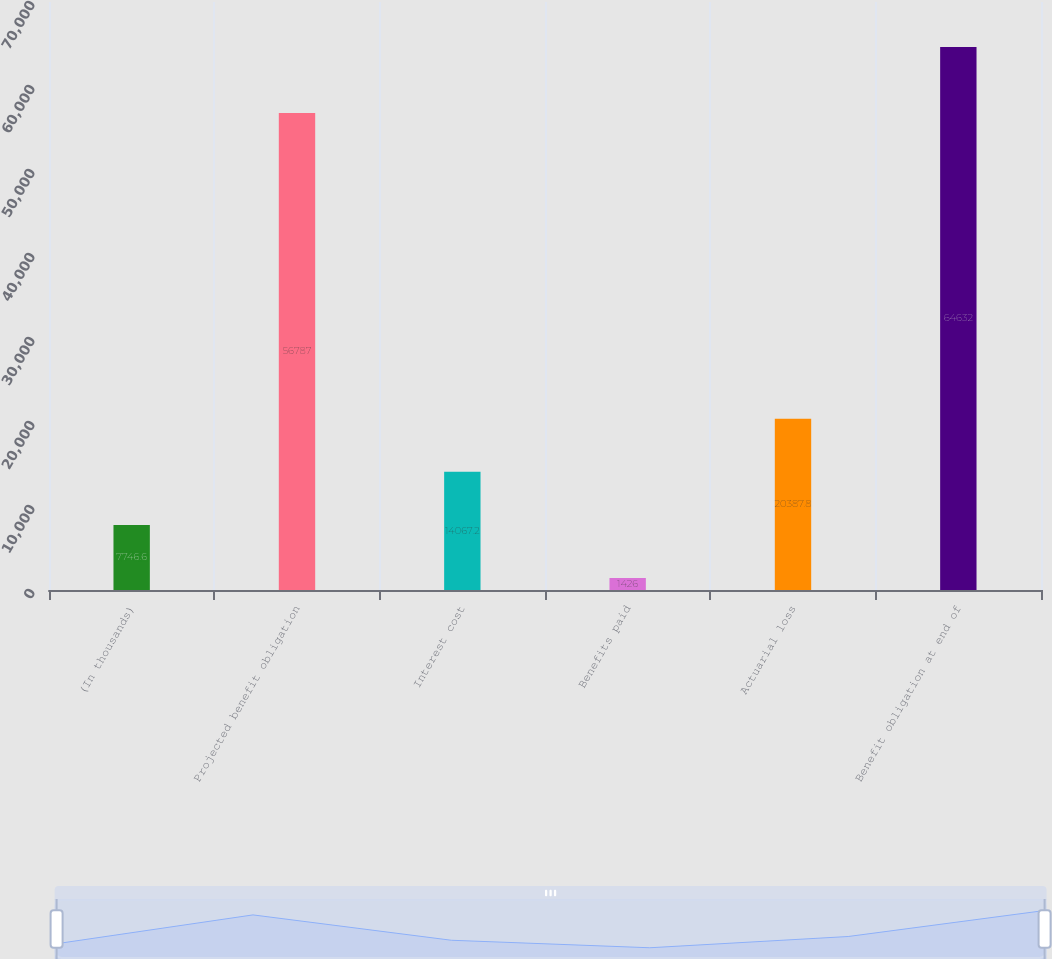Convert chart. <chart><loc_0><loc_0><loc_500><loc_500><bar_chart><fcel>(In thousands)<fcel>Projected benefit obligation<fcel>Interest cost<fcel>Benefits paid<fcel>Actuarial loss<fcel>Benefit obligation at end of<nl><fcel>7746.6<fcel>56787<fcel>14067.2<fcel>1426<fcel>20387.8<fcel>64632<nl></chart> 